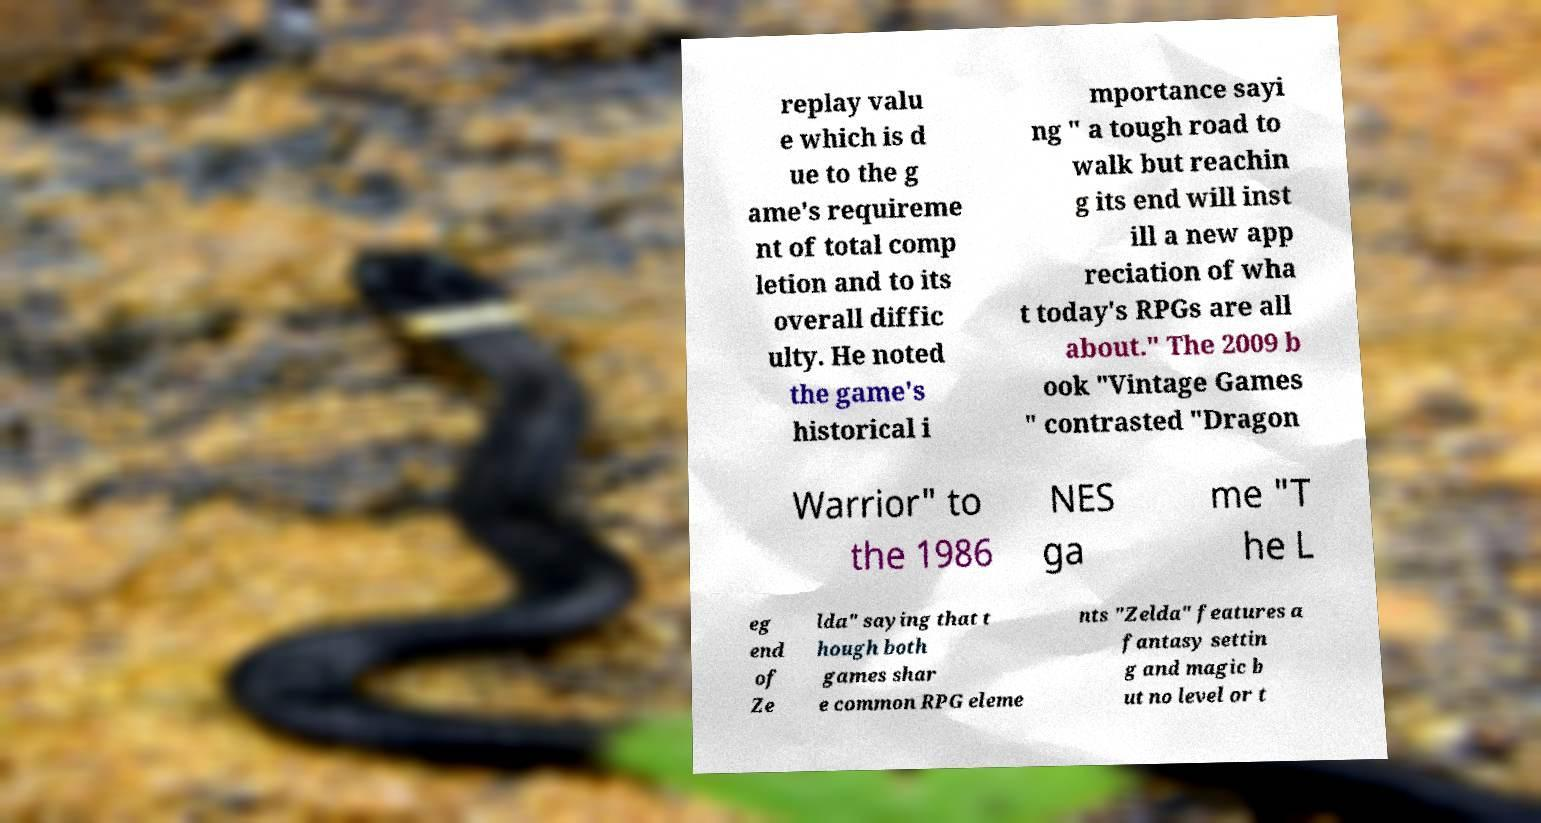Can you read and provide the text displayed in the image?This photo seems to have some interesting text. Can you extract and type it out for me? replay valu e which is d ue to the g ame's requireme nt of total comp letion and to its overall diffic ulty. He noted the game's historical i mportance sayi ng " a tough road to walk but reachin g its end will inst ill a new app reciation of wha t today's RPGs are all about." The 2009 b ook "Vintage Games " contrasted "Dragon Warrior" to the 1986 NES ga me "T he L eg end of Ze lda" saying that t hough both games shar e common RPG eleme nts "Zelda" features a fantasy settin g and magic b ut no level or t 